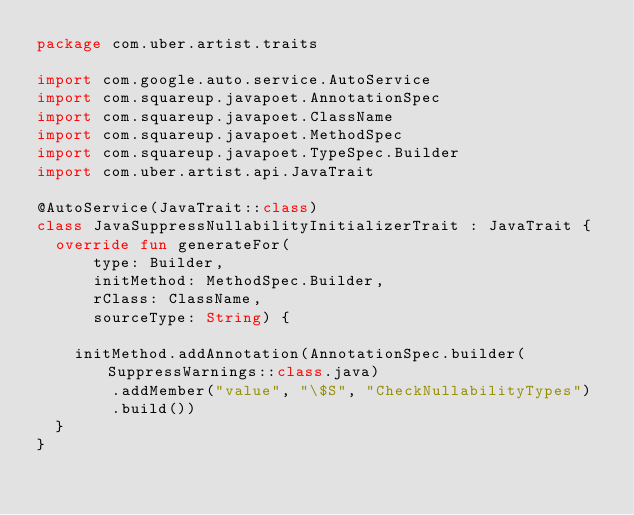<code> <loc_0><loc_0><loc_500><loc_500><_Kotlin_>package com.uber.artist.traits

import com.google.auto.service.AutoService
import com.squareup.javapoet.AnnotationSpec
import com.squareup.javapoet.ClassName
import com.squareup.javapoet.MethodSpec
import com.squareup.javapoet.TypeSpec.Builder
import com.uber.artist.api.JavaTrait

@AutoService(JavaTrait::class)
class JavaSuppressNullabilityInitializerTrait : JavaTrait {
  override fun generateFor(
      type: Builder,
      initMethod: MethodSpec.Builder,
      rClass: ClassName,
      sourceType: String) {

    initMethod.addAnnotation(AnnotationSpec.builder(SuppressWarnings::class.java)
        .addMember("value", "\$S", "CheckNullabilityTypes")
        .build())
  }
}

</code> 